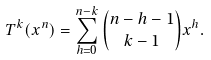<formula> <loc_0><loc_0><loc_500><loc_500>T ^ { k } ( x ^ { n } ) = \sum _ { h = 0 } ^ { n - k } { n - h - 1 \choose k - 1 } x ^ { h } .</formula> 